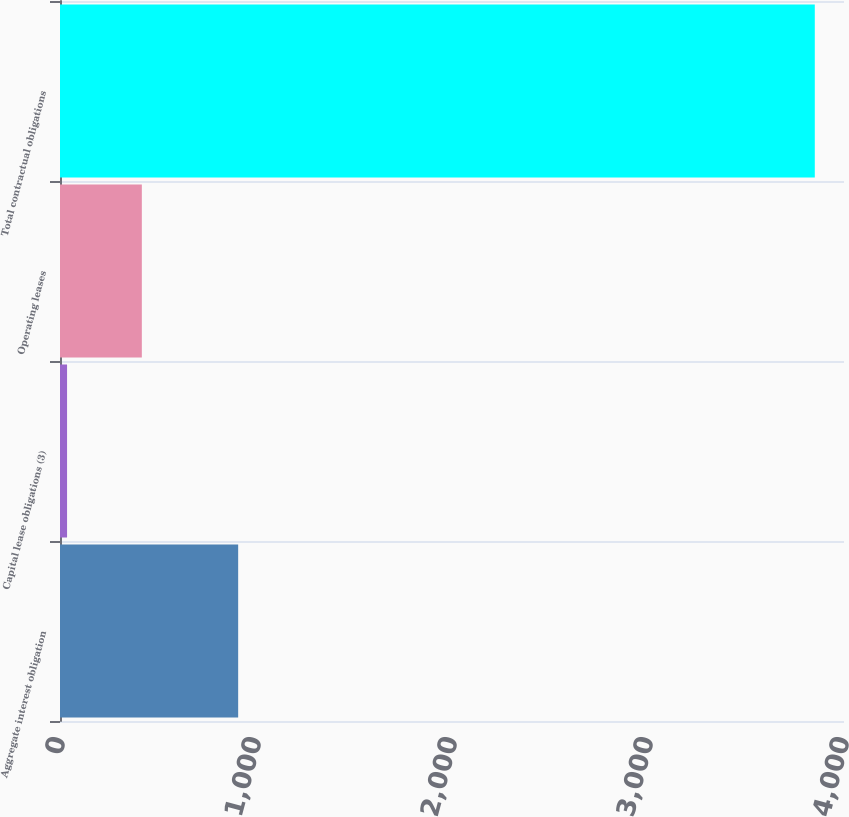Convert chart. <chart><loc_0><loc_0><loc_500><loc_500><bar_chart><fcel>Aggregate interest obligation<fcel>Capital lease obligations (3)<fcel>Operating leases<fcel>Total contractual obligations<nl><fcel>909<fcel>36<fcel>417.5<fcel>3851<nl></chart> 